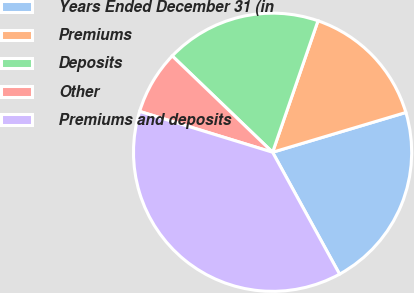Convert chart to OTSL. <chart><loc_0><loc_0><loc_500><loc_500><pie_chart><fcel>Years Ended December 31 (in<fcel>Premiums<fcel>Deposits<fcel>Other<fcel>Premiums and deposits<nl><fcel>21.62%<fcel>15.09%<fcel>18.12%<fcel>7.43%<fcel>37.74%<nl></chart> 